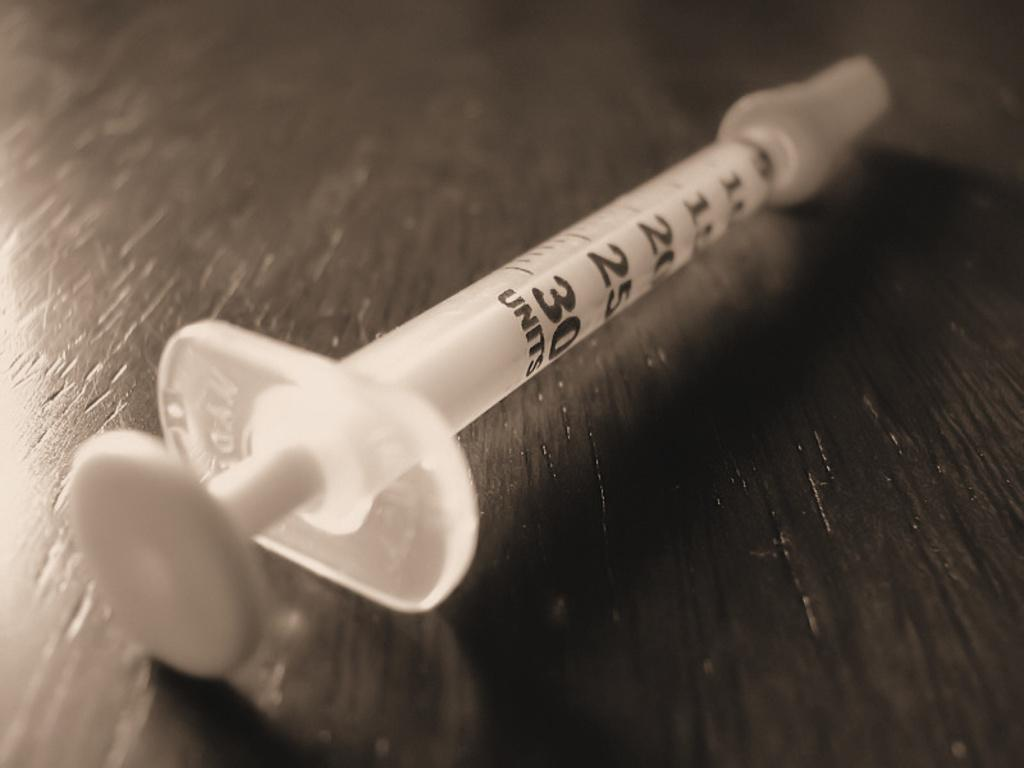What is the main object in the image? There is a syringe in the image. Can you describe the surface on which the syringe is placed? The syringe is on a wooden object. What type of bread is being used to power the engine in the image? There is no bread or engine present in the image; it only features a syringe on a wooden object. 